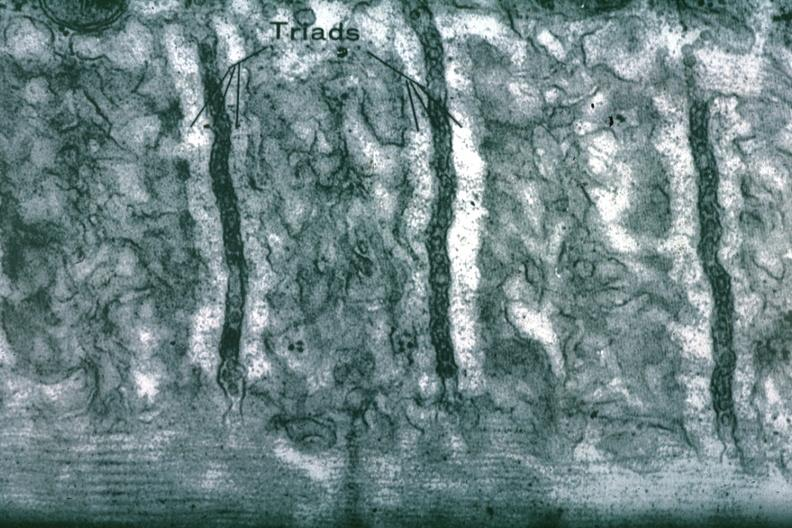what is present?
Answer the question using a single word or phrase. Cardiovascular 